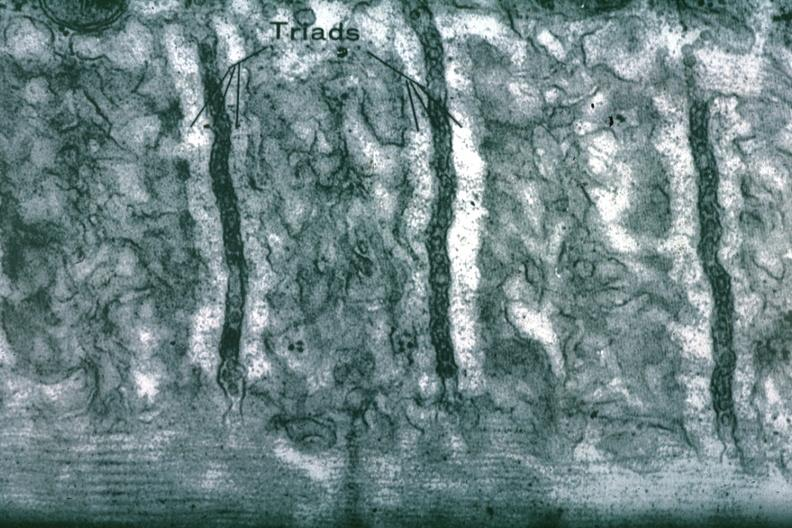what is present?
Answer the question using a single word or phrase. Cardiovascular 